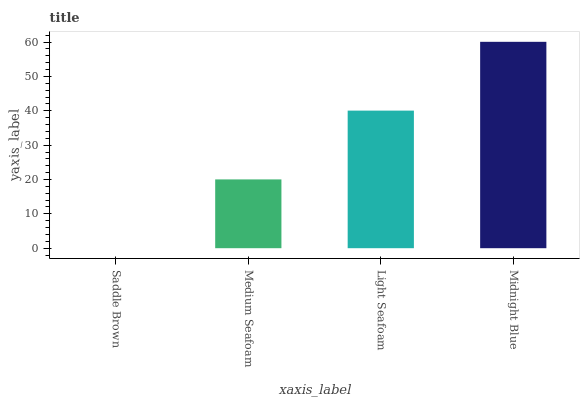Is Saddle Brown the minimum?
Answer yes or no. Yes. Is Midnight Blue the maximum?
Answer yes or no. Yes. Is Medium Seafoam the minimum?
Answer yes or no. No. Is Medium Seafoam the maximum?
Answer yes or no. No. Is Medium Seafoam greater than Saddle Brown?
Answer yes or no. Yes. Is Saddle Brown less than Medium Seafoam?
Answer yes or no. Yes. Is Saddle Brown greater than Medium Seafoam?
Answer yes or no. No. Is Medium Seafoam less than Saddle Brown?
Answer yes or no. No. Is Light Seafoam the high median?
Answer yes or no. Yes. Is Medium Seafoam the low median?
Answer yes or no. Yes. Is Saddle Brown the high median?
Answer yes or no. No. Is Saddle Brown the low median?
Answer yes or no. No. 